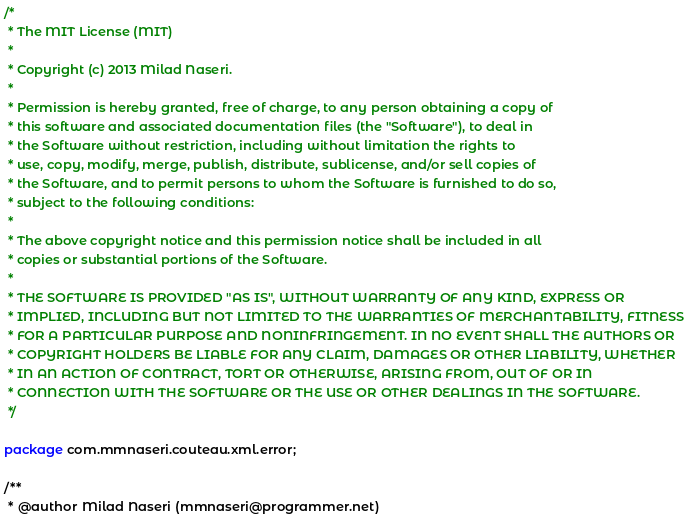<code> <loc_0><loc_0><loc_500><loc_500><_Java_>/*
 * The MIT License (MIT)
 *
 * Copyright (c) 2013 Milad Naseri.
 *
 * Permission is hereby granted, free of charge, to any person obtaining a copy of
 * this software and associated documentation files (the "Software"), to deal in
 * the Software without restriction, including without limitation the rights to
 * use, copy, modify, merge, publish, distribute, sublicense, and/or sell copies of
 * the Software, and to permit persons to whom the Software is furnished to do so,
 * subject to the following conditions:
 *
 * The above copyright notice and this permission notice shall be included in all
 * copies or substantial portions of the Software.
 *
 * THE SOFTWARE IS PROVIDED "AS IS", WITHOUT WARRANTY OF ANY KIND, EXPRESS OR
 * IMPLIED, INCLUDING BUT NOT LIMITED TO THE WARRANTIES OF MERCHANTABILITY, FITNESS
 * FOR A PARTICULAR PURPOSE AND NONINFRINGEMENT. IN NO EVENT SHALL THE AUTHORS OR
 * COPYRIGHT HOLDERS BE LIABLE FOR ANY CLAIM, DAMAGES OR OTHER LIABILITY, WHETHER
 * IN AN ACTION OF CONTRACT, TORT OR OTHERWISE, ARISING FROM, OUT OF OR IN
 * CONNECTION WITH THE SOFTWARE OR THE USE OR OTHER DEALINGS IN THE SOFTWARE.
 */

package com.mmnaseri.couteau.xml.error;

/**
 * @author Milad Naseri (mmnaseri@programmer.net)</code> 